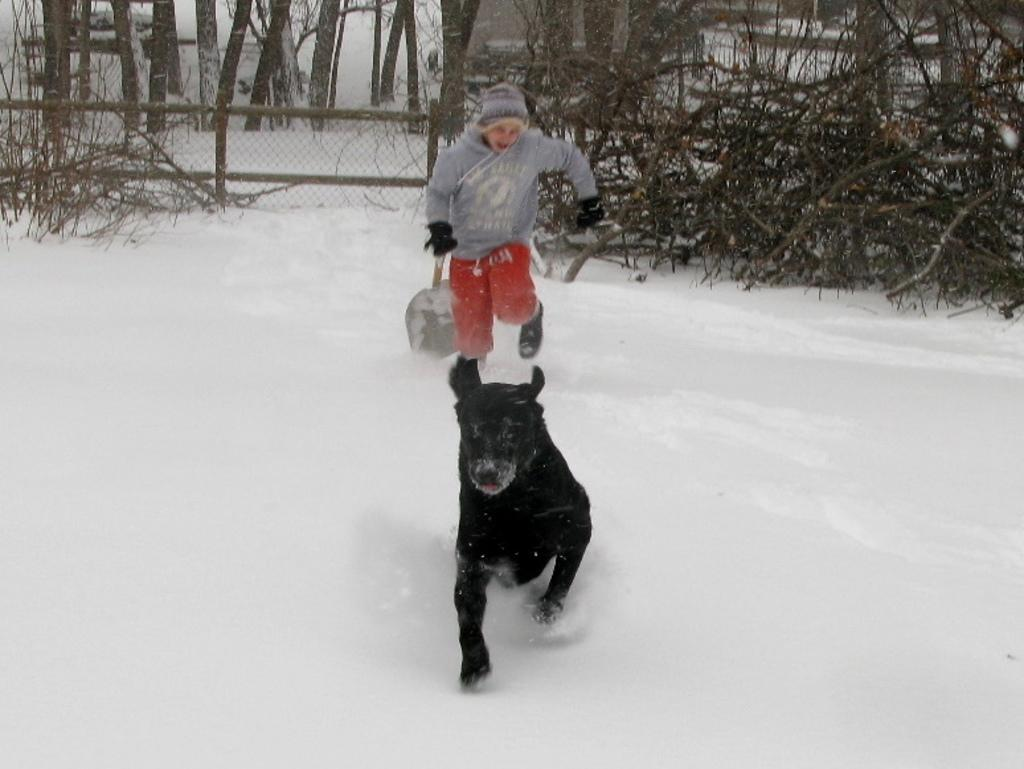What type of animal is present in the image? There is a dog in the image. Are there any humans in the image? Yes, there is a human in the image. What are the dog and the human doing in the image? Both the dog and the human are running. What is the ground covered with in the image? There is snow on the ground in the image. What can be seen in the background of the image? There are trees in the background of the image. What type of writing can be seen on the trees in the image? There is no writing visible on the trees in the image. 